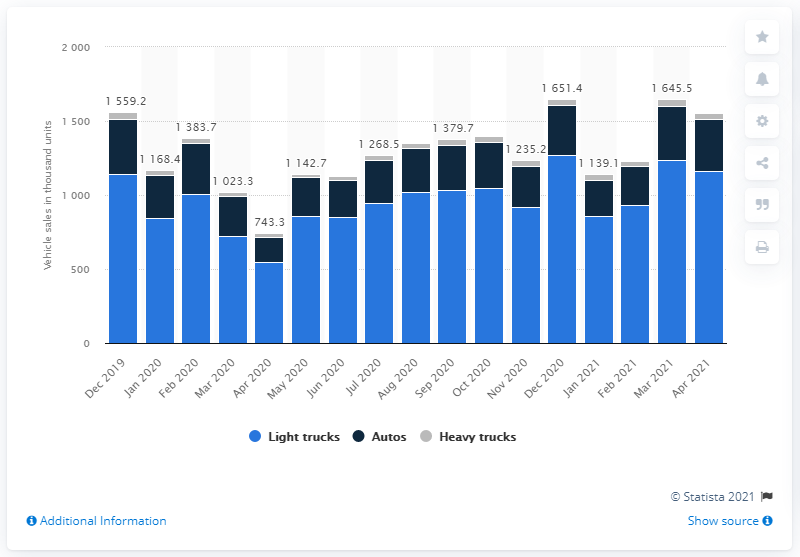List a handful of essential elements in this visual. In May 2020, the U.S. motor vehicle market experienced a significant rebound. 